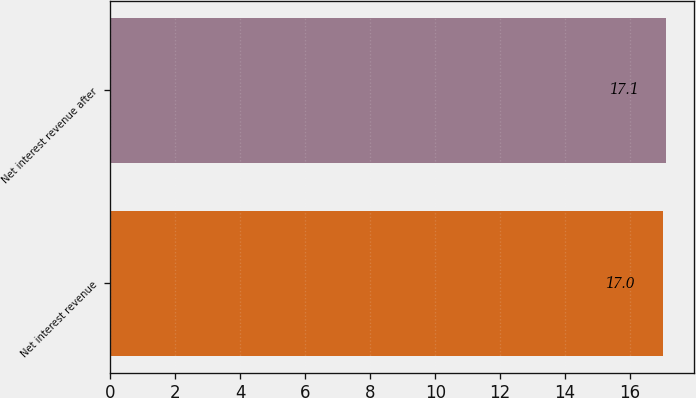Convert chart to OTSL. <chart><loc_0><loc_0><loc_500><loc_500><bar_chart><fcel>Net interest revenue<fcel>Net interest revenue after<nl><fcel>17<fcel>17.1<nl></chart> 